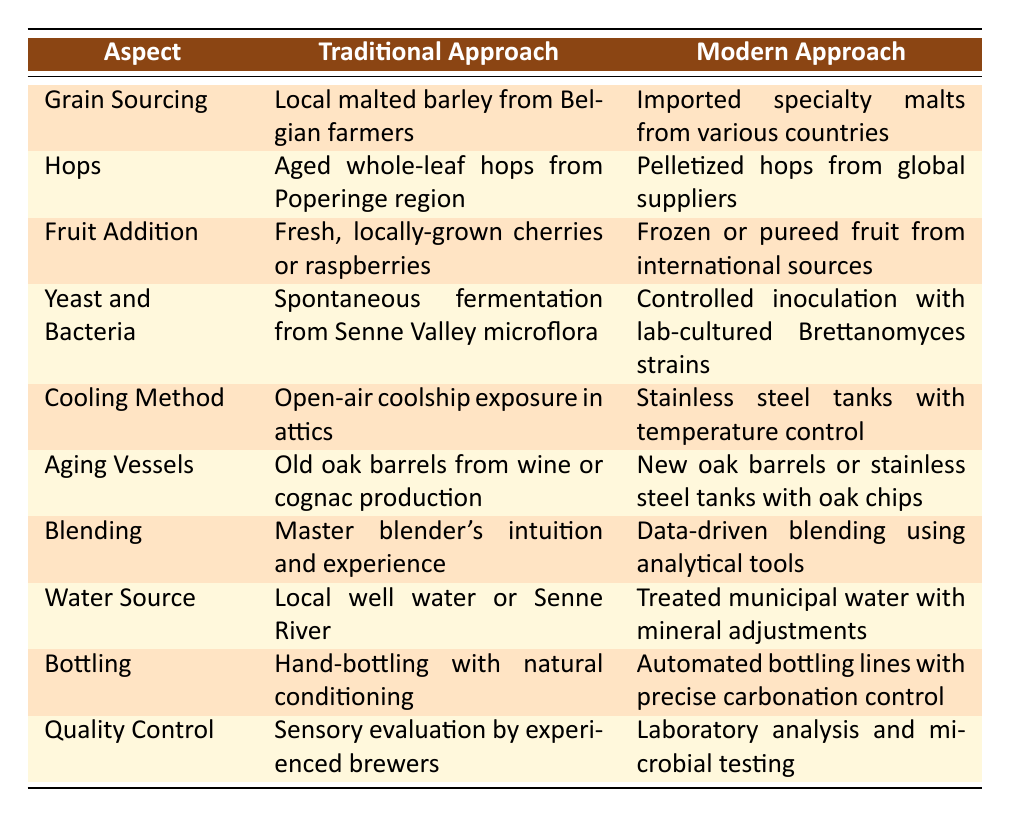What is the traditional method for grain sourcing? According to the table, the traditional method for grain sourcing involves using local malted barley from Belgian farmers. This specific detail can be found directly under the "Traditional Approach" column for "Grain Sourcing."
Answer: Local malted barley from Belgian farmers What type of hops is used in the modern approach? The table indicates that the modern approach for hops involves using pelletized hops from global suppliers. This information is directly located under the "Modern Approach" column for "Hops."
Answer: Pelletized hops from global suppliers Is there a difference in the water source between traditional and modern methods? Yes, the traditional approach uses local well water or the Senne River, while the modern approach uses treated municipal water with mineral adjustments. Both are specified in their respective columns for "Water Source."
Answer: Yes What kind of fermentation method is used traditionally for lambic beers? The traditional method uses spontaneous fermentation from Senne Valley microflora. This can be found in the "Yeast and Bacteria" row under the "Traditional Approach" column.
Answer: Spontaneous fermentation from Senne Valley microflora How do the aging vessels differ between traditional and modern approaches? The traditional approach utilizes old oak barrels from wine or cognac production, while the modern approach employs new oak barrels or stainless steel tanks with oak chips. Both methods are highlighted in the "Aging Vessels" section of the table.
Answer: Old oak barrels vs. new oak barrels or stainless steel tanks with oak chips What are the quality control methods used in the traditional approach? The traditional approach for quality control relies on sensory evaluation by experienced brewers, clearly stated under "Quality Control" in the traditional column.
Answer: Sensory evaluation by experienced brewers What can be inferred about the trends in ingredient sourcing for lambic beers? The trends indicate a movement from local, traditional methods to more globalized and controlled sourcing methods for ingredients like grains, hops, and fruits. This is evident when comparing the data in both traditional and modern columns across various aspects.
Answer: Trend towards globalized and controlled sourcing How is blending approached differently in traditional and modern methods? Traditional blending relies on the intuition and experience of the master blender, while modern blending employs data-driven techniques using analytical tools. This distinction is made in the "Blending" section of the table.
Answer: Intuition vs. data-driven blending 